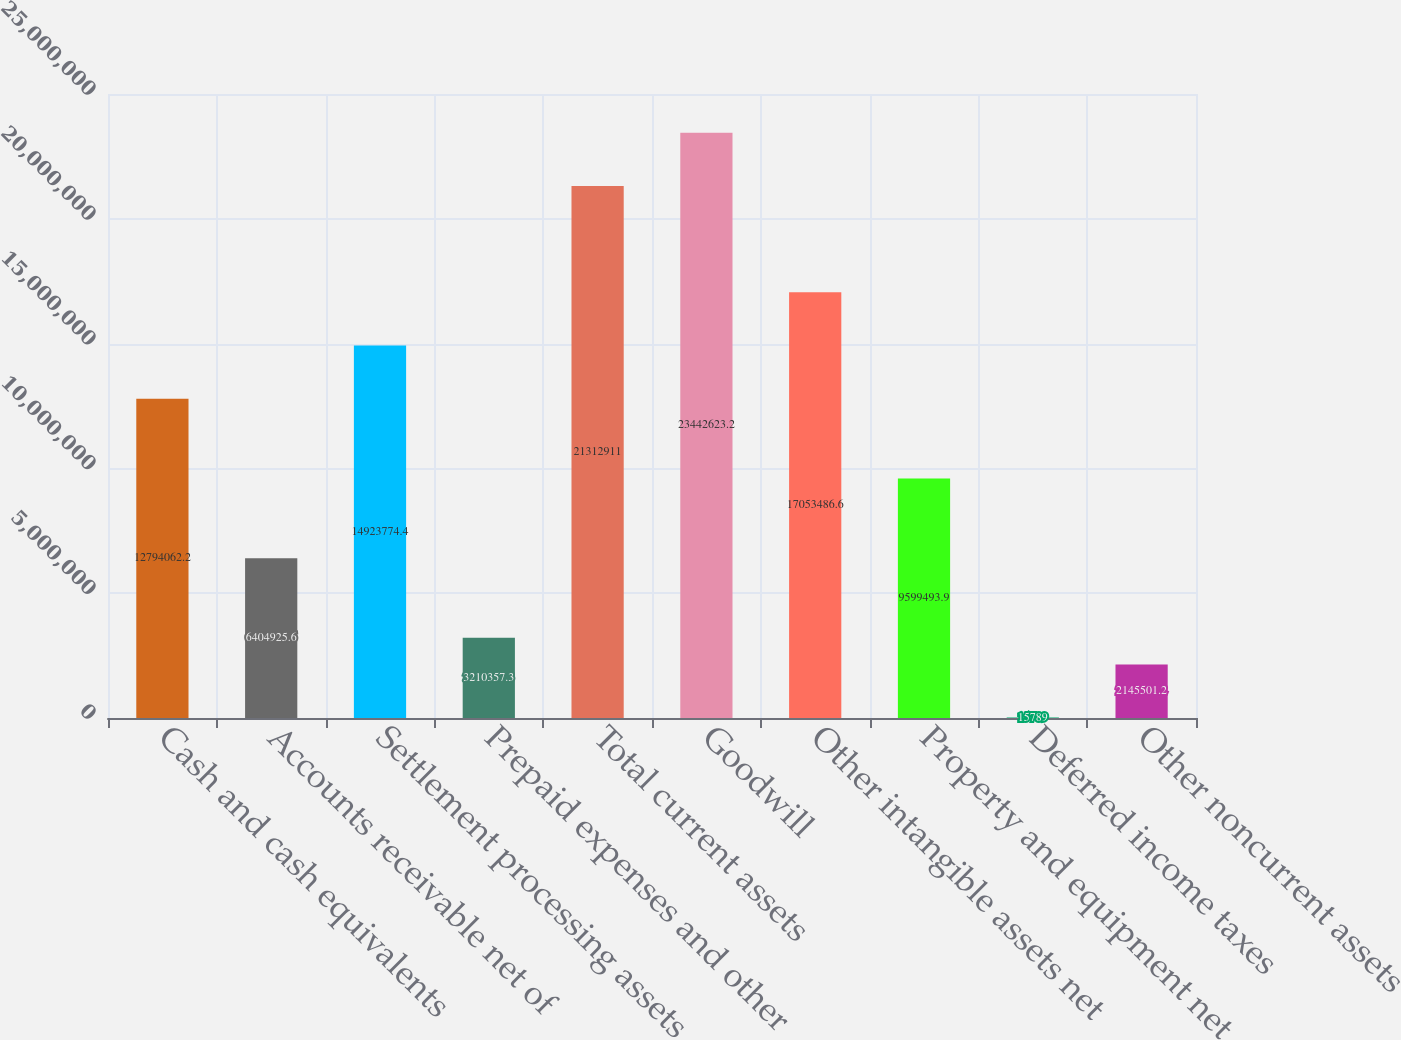Convert chart. <chart><loc_0><loc_0><loc_500><loc_500><bar_chart><fcel>Cash and cash equivalents<fcel>Accounts receivable net of<fcel>Settlement processing assets<fcel>Prepaid expenses and other<fcel>Total current assets<fcel>Goodwill<fcel>Other intangible assets net<fcel>Property and equipment net<fcel>Deferred income taxes<fcel>Other noncurrent assets<nl><fcel>1.27941e+07<fcel>6.40493e+06<fcel>1.49238e+07<fcel>3.21036e+06<fcel>2.13129e+07<fcel>2.34426e+07<fcel>1.70535e+07<fcel>9.59949e+06<fcel>15789<fcel>2.1455e+06<nl></chart> 